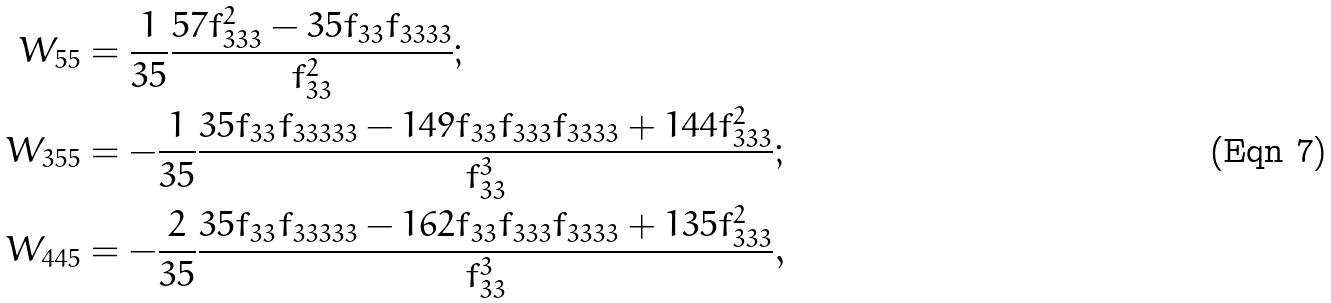Convert formula to latex. <formula><loc_0><loc_0><loc_500><loc_500>W _ { 5 5 } & = \frac { 1 } { 3 5 } \frac { 5 7 f _ { 3 3 3 } ^ { 2 } - 3 5 f _ { 3 3 } f _ { 3 3 3 3 } } { f _ { 3 3 } ^ { 2 } } ; \\ W _ { 3 5 5 } & = - \frac { 1 } { 3 5 } \frac { 3 5 f _ { 3 3 } f _ { 3 3 3 3 3 } - 1 4 9 f _ { 3 3 } f _ { 3 3 3 } f _ { 3 3 3 3 } + 1 4 4 f _ { 3 3 3 } ^ { 2 } } { f _ { 3 3 } ^ { 3 } } ; \\ W _ { 4 4 5 } & = - \frac { 2 } { 3 5 } \frac { 3 5 f _ { 3 3 } f _ { 3 3 3 3 3 } - 1 6 2 f _ { 3 3 } f _ { 3 3 3 } f _ { 3 3 3 3 } + 1 3 5 f _ { 3 3 3 } ^ { 2 } } { f _ { 3 3 } ^ { 3 } } ,</formula> 